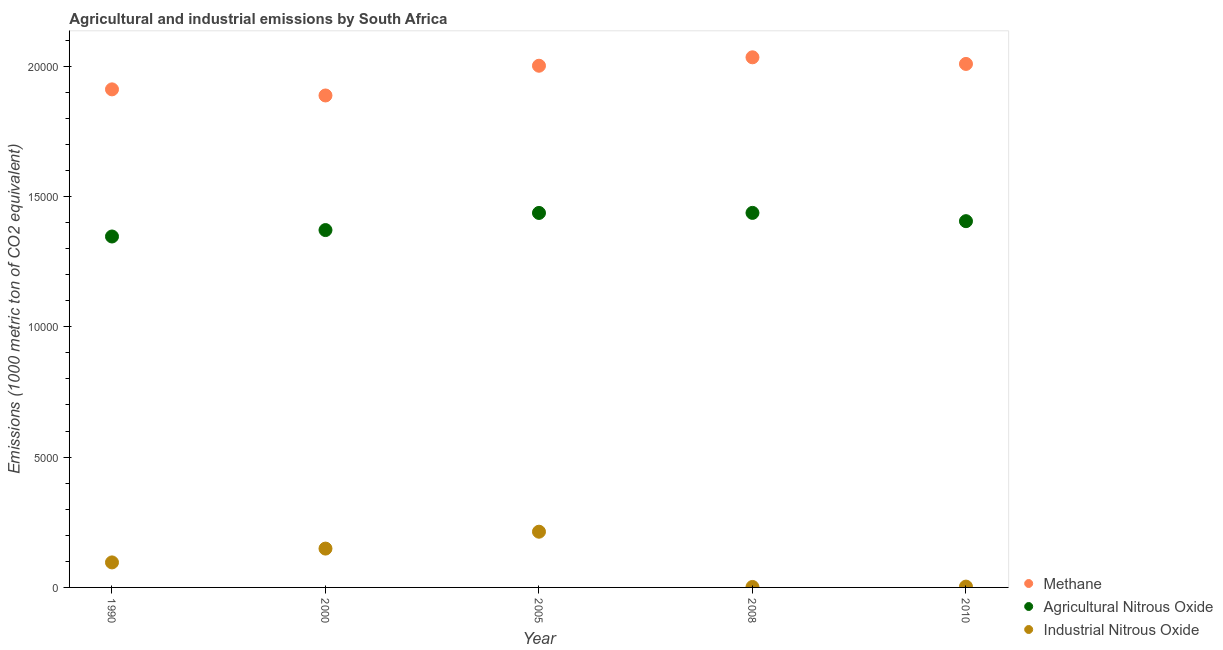How many different coloured dotlines are there?
Provide a short and direct response. 3. What is the amount of methane emissions in 2010?
Offer a terse response. 2.01e+04. Across all years, what is the maximum amount of methane emissions?
Give a very brief answer. 2.03e+04. In which year was the amount of methane emissions maximum?
Ensure brevity in your answer.  2008. What is the total amount of agricultural nitrous oxide emissions in the graph?
Your response must be concise. 7.00e+04. What is the difference between the amount of agricultural nitrous oxide emissions in 1990 and that in 2000?
Make the answer very short. -246.5. What is the difference between the amount of industrial nitrous oxide emissions in 1990 and the amount of agricultural nitrous oxide emissions in 2008?
Your response must be concise. -1.34e+04. What is the average amount of methane emissions per year?
Your answer should be very brief. 1.97e+04. In the year 1990, what is the difference between the amount of methane emissions and amount of agricultural nitrous oxide emissions?
Your response must be concise. 5644.8. What is the ratio of the amount of industrial nitrous oxide emissions in 2005 to that in 2008?
Keep it short and to the point. 119.41. What is the difference between the highest and the second highest amount of methane emissions?
Give a very brief answer. 254.3. What is the difference between the highest and the lowest amount of methane emissions?
Make the answer very short. 1464.3. Is the sum of the amount of industrial nitrous oxide emissions in 2000 and 2008 greater than the maximum amount of agricultural nitrous oxide emissions across all years?
Offer a terse response. No. Does the amount of methane emissions monotonically increase over the years?
Offer a very short reply. No. Is the amount of methane emissions strictly less than the amount of agricultural nitrous oxide emissions over the years?
Your answer should be very brief. No. How many years are there in the graph?
Your answer should be compact. 5. What is the difference between two consecutive major ticks on the Y-axis?
Your answer should be very brief. 5000. Does the graph contain any zero values?
Your response must be concise. No. Where does the legend appear in the graph?
Your answer should be very brief. Bottom right. How many legend labels are there?
Ensure brevity in your answer.  3. What is the title of the graph?
Your answer should be very brief. Agricultural and industrial emissions by South Africa. Does "Profit Tax" appear as one of the legend labels in the graph?
Ensure brevity in your answer.  No. What is the label or title of the Y-axis?
Keep it short and to the point. Emissions (1000 metric ton of CO2 equivalent). What is the Emissions (1000 metric ton of CO2 equivalent) in Methane in 1990?
Offer a very short reply. 1.91e+04. What is the Emissions (1000 metric ton of CO2 equivalent) of Agricultural Nitrous Oxide in 1990?
Provide a succinct answer. 1.35e+04. What is the Emissions (1000 metric ton of CO2 equivalent) of Industrial Nitrous Oxide in 1990?
Offer a very short reply. 959.8. What is the Emissions (1000 metric ton of CO2 equivalent) of Methane in 2000?
Provide a succinct answer. 1.89e+04. What is the Emissions (1000 metric ton of CO2 equivalent) of Agricultural Nitrous Oxide in 2000?
Provide a short and direct response. 1.37e+04. What is the Emissions (1000 metric ton of CO2 equivalent) of Industrial Nitrous Oxide in 2000?
Ensure brevity in your answer.  1489.9. What is the Emissions (1000 metric ton of CO2 equivalent) of Methane in 2005?
Offer a very short reply. 2.00e+04. What is the Emissions (1000 metric ton of CO2 equivalent) of Agricultural Nitrous Oxide in 2005?
Provide a succinct answer. 1.44e+04. What is the Emissions (1000 metric ton of CO2 equivalent) of Industrial Nitrous Oxide in 2005?
Ensure brevity in your answer.  2137.4. What is the Emissions (1000 metric ton of CO2 equivalent) of Methane in 2008?
Your answer should be very brief. 2.03e+04. What is the Emissions (1000 metric ton of CO2 equivalent) in Agricultural Nitrous Oxide in 2008?
Provide a succinct answer. 1.44e+04. What is the Emissions (1000 metric ton of CO2 equivalent) of Industrial Nitrous Oxide in 2008?
Offer a very short reply. 17.9. What is the Emissions (1000 metric ton of CO2 equivalent) of Methane in 2010?
Make the answer very short. 2.01e+04. What is the Emissions (1000 metric ton of CO2 equivalent) of Agricultural Nitrous Oxide in 2010?
Offer a very short reply. 1.41e+04. What is the Emissions (1000 metric ton of CO2 equivalent) in Industrial Nitrous Oxide in 2010?
Offer a terse response. 31.7. Across all years, what is the maximum Emissions (1000 metric ton of CO2 equivalent) of Methane?
Keep it short and to the point. 2.03e+04. Across all years, what is the maximum Emissions (1000 metric ton of CO2 equivalent) of Agricultural Nitrous Oxide?
Offer a very short reply. 1.44e+04. Across all years, what is the maximum Emissions (1000 metric ton of CO2 equivalent) of Industrial Nitrous Oxide?
Keep it short and to the point. 2137.4. Across all years, what is the minimum Emissions (1000 metric ton of CO2 equivalent) of Methane?
Provide a succinct answer. 1.89e+04. Across all years, what is the minimum Emissions (1000 metric ton of CO2 equivalent) of Agricultural Nitrous Oxide?
Offer a very short reply. 1.35e+04. What is the total Emissions (1000 metric ton of CO2 equivalent) in Methane in the graph?
Provide a short and direct response. 9.84e+04. What is the total Emissions (1000 metric ton of CO2 equivalent) in Agricultural Nitrous Oxide in the graph?
Give a very brief answer. 7.00e+04. What is the total Emissions (1000 metric ton of CO2 equivalent) of Industrial Nitrous Oxide in the graph?
Your response must be concise. 4636.7. What is the difference between the Emissions (1000 metric ton of CO2 equivalent) in Methane in 1990 and that in 2000?
Offer a terse response. 234.6. What is the difference between the Emissions (1000 metric ton of CO2 equivalent) of Agricultural Nitrous Oxide in 1990 and that in 2000?
Your answer should be very brief. -246.5. What is the difference between the Emissions (1000 metric ton of CO2 equivalent) in Industrial Nitrous Oxide in 1990 and that in 2000?
Provide a short and direct response. -530.1. What is the difference between the Emissions (1000 metric ton of CO2 equivalent) of Methane in 1990 and that in 2005?
Make the answer very short. -906.3. What is the difference between the Emissions (1000 metric ton of CO2 equivalent) in Agricultural Nitrous Oxide in 1990 and that in 2005?
Offer a terse response. -903.7. What is the difference between the Emissions (1000 metric ton of CO2 equivalent) of Industrial Nitrous Oxide in 1990 and that in 2005?
Provide a succinct answer. -1177.6. What is the difference between the Emissions (1000 metric ton of CO2 equivalent) of Methane in 1990 and that in 2008?
Give a very brief answer. -1229.7. What is the difference between the Emissions (1000 metric ton of CO2 equivalent) of Agricultural Nitrous Oxide in 1990 and that in 2008?
Your answer should be very brief. -905.7. What is the difference between the Emissions (1000 metric ton of CO2 equivalent) of Industrial Nitrous Oxide in 1990 and that in 2008?
Provide a short and direct response. 941.9. What is the difference between the Emissions (1000 metric ton of CO2 equivalent) in Methane in 1990 and that in 2010?
Give a very brief answer. -975.4. What is the difference between the Emissions (1000 metric ton of CO2 equivalent) of Agricultural Nitrous Oxide in 1990 and that in 2010?
Offer a terse response. -588.2. What is the difference between the Emissions (1000 metric ton of CO2 equivalent) in Industrial Nitrous Oxide in 1990 and that in 2010?
Offer a terse response. 928.1. What is the difference between the Emissions (1000 metric ton of CO2 equivalent) of Methane in 2000 and that in 2005?
Give a very brief answer. -1140.9. What is the difference between the Emissions (1000 metric ton of CO2 equivalent) in Agricultural Nitrous Oxide in 2000 and that in 2005?
Keep it short and to the point. -657.2. What is the difference between the Emissions (1000 metric ton of CO2 equivalent) of Industrial Nitrous Oxide in 2000 and that in 2005?
Keep it short and to the point. -647.5. What is the difference between the Emissions (1000 metric ton of CO2 equivalent) in Methane in 2000 and that in 2008?
Offer a very short reply. -1464.3. What is the difference between the Emissions (1000 metric ton of CO2 equivalent) in Agricultural Nitrous Oxide in 2000 and that in 2008?
Your answer should be compact. -659.2. What is the difference between the Emissions (1000 metric ton of CO2 equivalent) in Industrial Nitrous Oxide in 2000 and that in 2008?
Make the answer very short. 1472. What is the difference between the Emissions (1000 metric ton of CO2 equivalent) of Methane in 2000 and that in 2010?
Provide a succinct answer. -1210. What is the difference between the Emissions (1000 metric ton of CO2 equivalent) in Agricultural Nitrous Oxide in 2000 and that in 2010?
Offer a terse response. -341.7. What is the difference between the Emissions (1000 metric ton of CO2 equivalent) in Industrial Nitrous Oxide in 2000 and that in 2010?
Make the answer very short. 1458.2. What is the difference between the Emissions (1000 metric ton of CO2 equivalent) in Methane in 2005 and that in 2008?
Give a very brief answer. -323.4. What is the difference between the Emissions (1000 metric ton of CO2 equivalent) of Agricultural Nitrous Oxide in 2005 and that in 2008?
Offer a terse response. -2. What is the difference between the Emissions (1000 metric ton of CO2 equivalent) in Industrial Nitrous Oxide in 2005 and that in 2008?
Give a very brief answer. 2119.5. What is the difference between the Emissions (1000 metric ton of CO2 equivalent) in Methane in 2005 and that in 2010?
Make the answer very short. -69.1. What is the difference between the Emissions (1000 metric ton of CO2 equivalent) of Agricultural Nitrous Oxide in 2005 and that in 2010?
Keep it short and to the point. 315.5. What is the difference between the Emissions (1000 metric ton of CO2 equivalent) of Industrial Nitrous Oxide in 2005 and that in 2010?
Make the answer very short. 2105.7. What is the difference between the Emissions (1000 metric ton of CO2 equivalent) in Methane in 2008 and that in 2010?
Offer a very short reply. 254.3. What is the difference between the Emissions (1000 metric ton of CO2 equivalent) of Agricultural Nitrous Oxide in 2008 and that in 2010?
Make the answer very short. 317.5. What is the difference between the Emissions (1000 metric ton of CO2 equivalent) of Industrial Nitrous Oxide in 2008 and that in 2010?
Your response must be concise. -13.8. What is the difference between the Emissions (1000 metric ton of CO2 equivalent) of Methane in 1990 and the Emissions (1000 metric ton of CO2 equivalent) of Agricultural Nitrous Oxide in 2000?
Your response must be concise. 5398.3. What is the difference between the Emissions (1000 metric ton of CO2 equivalent) of Methane in 1990 and the Emissions (1000 metric ton of CO2 equivalent) of Industrial Nitrous Oxide in 2000?
Ensure brevity in your answer.  1.76e+04. What is the difference between the Emissions (1000 metric ton of CO2 equivalent) in Agricultural Nitrous Oxide in 1990 and the Emissions (1000 metric ton of CO2 equivalent) in Industrial Nitrous Oxide in 2000?
Provide a succinct answer. 1.20e+04. What is the difference between the Emissions (1000 metric ton of CO2 equivalent) in Methane in 1990 and the Emissions (1000 metric ton of CO2 equivalent) in Agricultural Nitrous Oxide in 2005?
Give a very brief answer. 4741.1. What is the difference between the Emissions (1000 metric ton of CO2 equivalent) of Methane in 1990 and the Emissions (1000 metric ton of CO2 equivalent) of Industrial Nitrous Oxide in 2005?
Offer a very short reply. 1.70e+04. What is the difference between the Emissions (1000 metric ton of CO2 equivalent) of Agricultural Nitrous Oxide in 1990 and the Emissions (1000 metric ton of CO2 equivalent) of Industrial Nitrous Oxide in 2005?
Ensure brevity in your answer.  1.13e+04. What is the difference between the Emissions (1000 metric ton of CO2 equivalent) of Methane in 1990 and the Emissions (1000 metric ton of CO2 equivalent) of Agricultural Nitrous Oxide in 2008?
Make the answer very short. 4739.1. What is the difference between the Emissions (1000 metric ton of CO2 equivalent) in Methane in 1990 and the Emissions (1000 metric ton of CO2 equivalent) in Industrial Nitrous Oxide in 2008?
Offer a very short reply. 1.91e+04. What is the difference between the Emissions (1000 metric ton of CO2 equivalent) of Agricultural Nitrous Oxide in 1990 and the Emissions (1000 metric ton of CO2 equivalent) of Industrial Nitrous Oxide in 2008?
Make the answer very short. 1.34e+04. What is the difference between the Emissions (1000 metric ton of CO2 equivalent) in Methane in 1990 and the Emissions (1000 metric ton of CO2 equivalent) in Agricultural Nitrous Oxide in 2010?
Offer a terse response. 5056.6. What is the difference between the Emissions (1000 metric ton of CO2 equivalent) of Methane in 1990 and the Emissions (1000 metric ton of CO2 equivalent) of Industrial Nitrous Oxide in 2010?
Offer a terse response. 1.91e+04. What is the difference between the Emissions (1000 metric ton of CO2 equivalent) of Agricultural Nitrous Oxide in 1990 and the Emissions (1000 metric ton of CO2 equivalent) of Industrial Nitrous Oxide in 2010?
Your response must be concise. 1.34e+04. What is the difference between the Emissions (1000 metric ton of CO2 equivalent) of Methane in 2000 and the Emissions (1000 metric ton of CO2 equivalent) of Agricultural Nitrous Oxide in 2005?
Offer a very short reply. 4506.5. What is the difference between the Emissions (1000 metric ton of CO2 equivalent) of Methane in 2000 and the Emissions (1000 metric ton of CO2 equivalent) of Industrial Nitrous Oxide in 2005?
Your response must be concise. 1.67e+04. What is the difference between the Emissions (1000 metric ton of CO2 equivalent) in Agricultural Nitrous Oxide in 2000 and the Emissions (1000 metric ton of CO2 equivalent) in Industrial Nitrous Oxide in 2005?
Your response must be concise. 1.16e+04. What is the difference between the Emissions (1000 metric ton of CO2 equivalent) of Methane in 2000 and the Emissions (1000 metric ton of CO2 equivalent) of Agricultural Nitrous Oxide in 2008?
Make the answer very short. 4504.5. What is the difference between the Emissions (1000 metric ton of CO2 equivalent) in Methane in 2000 and the Emissions (1000 metric ton of CO2 equivalent) in Industrial Nitrous Oxide in 2008?
Your answer should be compact. 1.89e+04. What is the difference between the Emissions (1000 metric ton of CO2 equivalent) of Agricultural Nitrous Oxide in 2000 and the Emissions (1000 metric ton of CO2 equivalent) of Industrial Nitrous Oxide in 2008?
Provide a short and direct response. 1.37e+04. What is the difference between the Emissions (1000 metric ton of CO2 equivalent) of Methane in 2000 and the Emissions (1000 metric ton of CO2 equivalent) of Agricultural Nitrous Oxide in 2010?
Your answer should be compact. 4822. What is the difference between the Emissions (1000 metric ton of CO2 equivalent) of Methane in 2000 and the Emissions (1000 metric ton of CO2 equivalent) of Industrial Nitrous Oxide in 2010?
Give a very brief answer. 1.88e+04. What is the difference between the Emissions (1000 metric ton of CO2 equivalent) in Agricultural Nitrous Oxide in 2000 and the Emissions (1000 metric ton of CO2 equivalent) in Industrial Nitrous Oxide in 2010?
Make the answer very short. 1.37e+04. What is the difference between the Emissions (1000 metric ton of CO2 equivalent) in Methane in 2005 and the Emissions (1000 metric ton of CO2 equivalent) in Agricultural Nitrous Oxide in 2008?
Offer a very short reply. 5645.4. What is the difference between the Emissions (1000 metric ton of CO2 equivalent) of Methane in 2005 and the Emissions (1000 metric ton of CO2 equivalent) of Industrial Nitrous Oxide in 2008?
Ensure brevity in your answer.  2.00e+04. What is the difference between the Emissions (1000 metric ton of CO2 equivalent) in Agricultural Nitrous Oxide in 2005 and the Emissions (1000 metric ton of CO2 equivalent) in Industrial Nitrous Oxide in 2008?
Give a very brief answer. 1.43e+04. What is the difference between the Emissions (1000 metric ton of CO2 equivalent) of Methane in 2005 and the Emissions (1000 metric ton of CO2 equivalent) of Agricultural Nitrous Oxide in 2010?
Keep it short and to the point. 5962.9. What is the difference between the Emissions (1000 metric ton of CO2 equivalent) in Methane in 2005 and the Emissions (1000 metric ton of CO2 equivalent) in Industrial Nitrous Oxide in 2010?
Provide a short and direct response. 2.00e+04. What is the difference between the Emissions (1000 metric ton of CO2 equivalent) in Agricultural Nitrous Oxide in 2005 and the Emissions (1000 metric ton of CO2 equivalent) in Industrial Nitrous Oxide in 2010?
Ensure brevity in your answer.  1.43e+04. What is the difference between the Emissions (1000 metric ton of CO2 equivalent) in Methane in 2008 and the Emissions (1000 metric ton of CO2 equivalent) in Agricultural Nitrous Oxide in 2010?
Your response must be concise. 6286.3. What is the difference between the Emissions (1000 metric ton of CO2 equivalent) of Methane in 2008 and the Emissions (1000 metric ton of CO2 equivalent) of Industrial Nitrous Oxide in 2010?
Your response must be concise. 2.03e+04. What is the difference between the Emissions (1000 metric ton of CO2 equivalent) of Agricultural Nitrous Oxide in 2008 and the Emissions (1000 metric ton of CO2 equivalent) of Industrial Nitrous Oxide in 2010?
Ensure brevity in your answer.  1.43e+04. What is the average Emissions (1000 metric ton of CO2 equivalent) in Methane per year?
Ensure brevity in your answer.  1.97e+04. What is the average Emissions (1000 metric ton of CO2 equivalent) of Agricultural Nitrous Oxide per year?
Keep it short and to the point. 1.40e+04. What is the average Emissions (1000 metric ton of CO2 equivalent) of Industrial Nitrous Oxide per year?
Provide a succinct answer. 927.34. In the year 1990, what is the difference between the Emissions (1000 metric ton of CO2 equivalent) of Methane and Emissions (1000 metric ton of CO2 equivalent) of Agricultural Nitrous Oxide?
Offer a terse response. 5644.8. In the year 1990, what is the difference between the Emissions (1000 metric ton of CO2 equivalent) of Methane and Emissions (1000 metric ton of CO2 equivalent) of Industrial Nitrous Oxide?
Your response must be concise. 1.81e+04. In the year 1990, what is the difference between the Emissions (1000 metric ton of CO2 equivalent) in Agricultural Nitrous Oxide and Emissions (1000 metric ton of CO2 equivalent) in Industrial Nitrous Oxide?
Ensure brevity in your answer.  1.25e+04. In the year 2000, what is the difference between the Emissions (1000 metric ton of CO2 equivalent) of Methane and Emissions (1000 metric ton of CO2 equivalent) of Agricultural Nitrous Oxide?
Ensure brevity in your answer.  5163.7. In the year 2000, what is the difference between the Emissions (1000 metric ton of CO2 equivalent) of Methane and Emissions (1000 metric ton of CO2 equivalent) of Industrial Nitrous Oxide?
Keep it short and to the point. 1.74e+04. In the year 2000, what is the difference between the Emissions (1000 metric ton of CO2 equivalent) in Agricultural Nitrous Oxide and Emissions (1000 metric ton of CO2 equivalent) in Industrial Nitrous Oxide?
Your response must be concise. 1.22e+04. In the year 2005, what is the difference between the Emissions (1000 metric ton of CO2 equivalent) of Methane and Emissions (1000 metric ton of CO2 equivalent) of Agricultural Nitrous Oxide?
Provide a succinct answer. 5647.4. In the year 2005, what is the difference between the Emissions (1000 metric ton of CO2 equivalent) of Methane and Emissions (1000 metric ton of CO2 equivalent) of Industrial Nitrous Oxide?
Your answer should be very brief. 1.79e+04. In the year 2005, what is the difference between the Emissions (1000 metric ton of CO2 equivalent) of Agricultural Nitrous Oxide and Emissions (1000 metric ton of CO2 equivalent) of Industrial Nitrous Oxide?
Keep it short and to the point. 1.22e+04. In the year 2008, what is the difference between the Emissions (1000 metric ton of CO2 equivalent) of Methane and Emissions (1000 metric ton of CO2 equivalent) of Agricultural Nitrous Oxide?
Offer a very short reply. 5968.8. In the year 2008, what is the difference between the Emissions (1000 metric ton of CO2 equivalent) in Methane and Emissions (1000 metric ton of CO2 equivalent) in Industrial Nitrous Oxide?
Keep it short and to the point. 2.03e+04. In the year 2008, what is the difference between the Emissions (1000 metric ton of CO2 equivalent) of Agricultural Nitrous Oxide and Emissions (1000 metric ton of CO2 equivalent) of Industrial Nitrous Oxide?
Make the answer very short. 1.44e+04. In the year 2010, what is the difference between the Emissions (1000 metric ton of CO2 equivalent) in Methane and Emissions (1000 metric ton of CO2 equivalent) in Agricultural Nitrous Oxide?
Your answer should be compact. 6032. In the year 2010, what is the difference between the Emissions (1000 metric ton of CO2 equivalent) of Methane and Emissions (1000 metric ton of CO2 equivalent) of Industrial Nitrous Oxide?
Ensure brevity in your answer.  2.01e+04. In the year 2010, what is the difference between the Emissions (1000 metric ton of CO2 equivalent) in Agricultural Nitrous Oxide and Emissions (1000 metric ton of CO2 equivalent) in Industrial Nitrous Oxide?
Your response must be concise. 1.40e+04. What is the ratio of the Emissions (1000 metric ton of CO2 equivalent) of Methane in 1990 to that in 2000?
Your answer should be very brief. 1.01. What is the ratio of the Emissions (1000 metric ton of CO2 equivalent) of Agricultural Nitrous Oxide in 1990 to that in 2000?
Make the answer very short. 0.98. What is the ratio of the Emissions (1000 metric ton of CO2 equivalent) of Industrial Nitrous Oxide in 1990 to that in 2000?
Your answer should be very brief. 0.64. What is the ratio of the Emissions (1000 metric ton of CO2 equivalent) in Methane in 1990 to that in 2005?
Provide a short and direct response. 0.95. What is the ratio of the Emissions (1000 metric ton of CO2 equivalent) of Agricultural Nitrous Oxide in 1990 to that in 2005?
Your response must be concise. 0.94. What is the ratio of the Emissions (1000 metric ton of CO2 equivalent) in Industrial Nitrous Oxide in 1990 to that in 2005?
Offer a very short reply. 0.45. What is the ratio of the Emissions (1000 metric ton of CO2 equivalent) in Methane in 1990 to that in 2008?
Your answer should be compact. 0.94. What is the ratio of the Emissions (1000 metric ton of CO2 equivalent) in Agricultural Nitrous Oxide in 1990 to that in 2008?
Offer a very short reply. 0.94. What is the ratio of the Emissions (1000 metric ton of CO2 equivalent) of Industrial Nitrous Oxide in 1990 to that in 2008?
Provide a succinct answer. 53.62. What is the ratio of the Emissions (1000 metric ton of CO2 equivalent) of Methane in 1990 to that in 2010?
Your answer should be compact. 0.95. What is the ratio of the Emissions (1000 metric ton of CO2 equivalent) in Agricultural Nitrous Oxide in 1990 to that in 2010?
Your answer should be compact. 0.96. What is the ratio of the Emissions (1000 metric ton of CO2 equivalent) in Industrial Nitrous Oxide in 1990 to that in 2010?
Provide a short and direct response. 30.28. What is the ratio of the Emissions (1000 metric ton of CO2 equivalent) of Methane in 2000 to that in 2005?
Keep it short and to the point. 0.94. What is the ratio of the Emissions (1000 metric ton of CO2 equivalent) in Agricultural Nitrous Oxide in 2000 to that in 2005?
Give a very brief answer. 0.95. What is the ratio of the Emissions (1000 metric ton of CO2 equivalent) of Industrial Nitrous Oxide in 2000 to that in 2005?
Keep it short and to the point. 0.7. What is the ratio of the Emissions (1000 metric ton of CO2 equivalent) of Methane in 2000 to that in 2008?
Keep it short and to the point. 0.93. What is the ratio of the Emissions (1000 metric ton of CO2 equivalent) in Agricultural Nitrous Oxide in 2000 to that in 2008?
Provide a short and direct response. 0.95. What is the ratio of the Emissions (1000 metric ton of CO2 equivalent) in Industrial Nitrous Oxide in 2000 to that in 2008?
Offer a very short reply. 83.23. What is the ratio of the Emissions (1000 metric ton of CO2 equivalent) of Methane in 2000 to that in 2010?
Offer a terse response. 0.94. What is the ratio of the Emissions (1000 metric ton of CO2 equivalent) in Agricultural Nitrous Oxide in 2000 to that in 2010?
Your response must be concise. 0.98. What is the ratio of the Emissions (1000 metric ton of CO2 equivalent) of Methane in 2005 to that in 2008?
Your answer should be very brief. 0.98. What is the ratio of the Emissions (1000 metric ton of CO2 equivalent) in Agricultural Nitrous Oxide in 2005 to that in 2008?
Your answer should be compact. 1. What is the ratio of the Emissions (1000 metric ton of CO2 equivalent) of Industrial Nitrous Oxide in 2005 to that in 2008?
Offer a very short reply. 119.41. What is the ratio of the Emissions (1000 metric ton of CO2 equivalent) in Methane in 2005 to that in 2010?
Provide a succinct answer. 1. What is the ratio of the Emissions (1000 metric ton of CO2 equivalent) of Agricultural Nitrous Oxide in 2005 to that in 2010?
Provide a short and direct response. 1.02. What is the ratio of the Emissions (1000 metric ton of CO2 equivalent) of Industrial Nitrous Oxide in 2005 to that in 2010?
Your answer should be very brief. 67.43. What is the ratio of the Emissions (1000 metric ton of CO2 equivalent) of Methane in 2008 to that in 2010?
Your response must be concise. 1.01. What is the ratio of the Emissions (1000 metric ton of CO2 equivalent) in Agricultural Nitrous Oxide in 2008 to that in 2010?
Offer a terse response. 1.02. What is the ratio of the Emissions (1000 metric ton of CO2 equivalent) in Industrial Nitrous Oxide in 2008 to that in 2010?
Ensure brevity in your answer.  0.56. What is the difference between the highest and the second highest Emissions (1000 metric ton of CO2 equivalent) of Methane?
Your answer should be very brief. 254.3. What is the difference between the highest and the second highest Emissions (1000 metric ton of CO2 equivalent) in Agricultural Nitrous Oxide?
Provide a short and direct response. 2. What is the difference between the highest and the second highest Emissions (1000 metric ton of CO2 equivalent) of Industrial Nitrous Oxide?
Your answer should be compact. 647.5. What is the difference between the highest and the lowest Emissions (1000 metric ton of CO2 equivalent) of Methane?
Give a very brief answer. 1464.3. What is the difference between the highest and the lowest Emissions (1000 metric ton of CO2 equivalent) of Agricultural Nitrous Oxide?
Offer a terse response. 905.7. What is the difference between the highest and the lowest Emissions (1000 metric ton of CO2 equivalent) of Industrial Nitrous Oxide?
Keep it short and to the point. 2119.5. 